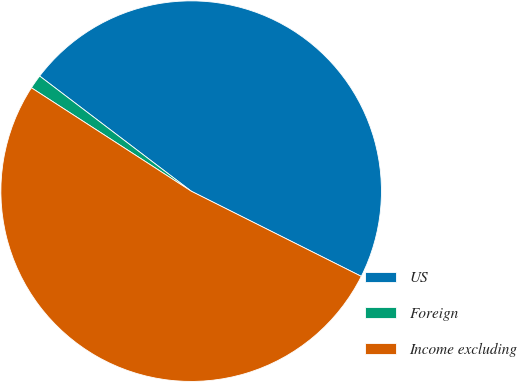<chart> <loc_0><loc_0><loc_500><loc_500><pie_chart><fcel>US<fcel>Foreign<fcel>Income excluding<nl><fcel>47.05%<fcel>1.2%<fcel>51.75%<nl></chart> 